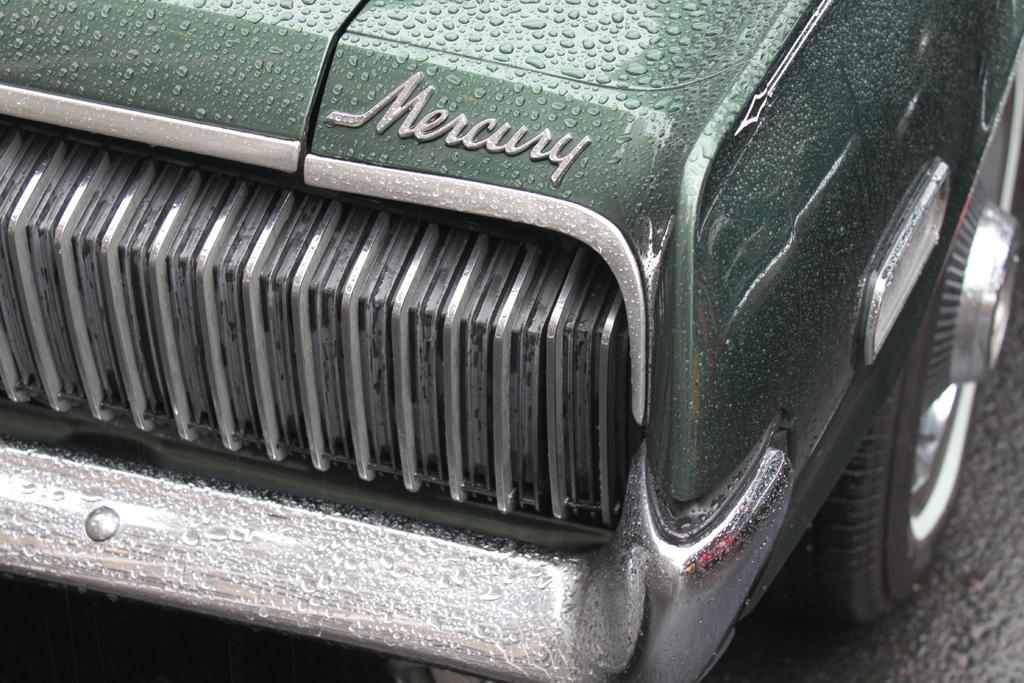What is the color of the vehicle in the image? The vehicle in the image is green. Can you describe any specific features of the vehicle? Yes, there is a tire on the right side of the vehicle, and there is a silver-colored bumper on the vehicle. Is there a fan visible in the image? No, there is no fan present in the image. Can you describe the man standing next to the vehicle in the image? There is no man present in the image; it only shows the green vehicle with a tire on the right side and a silver-colored bumper. 